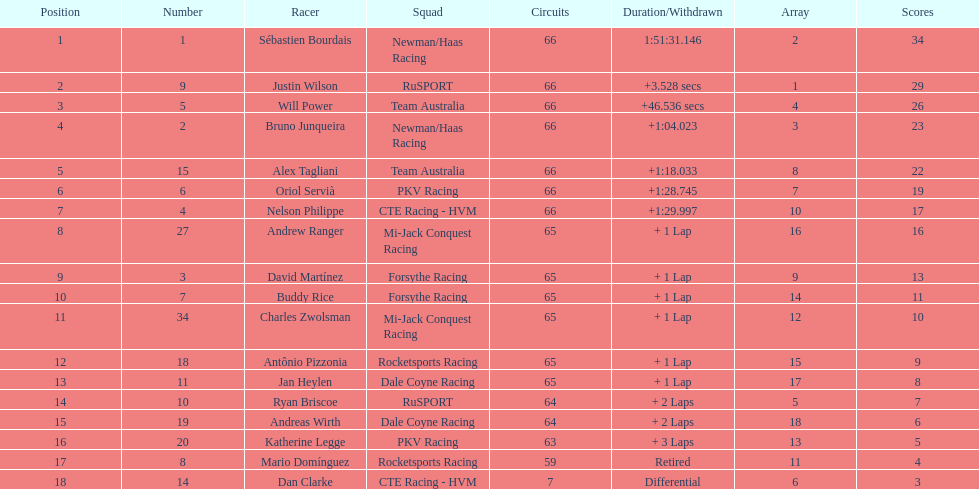Which driver has the same number as his/her position? Sébastien Bourdais. 